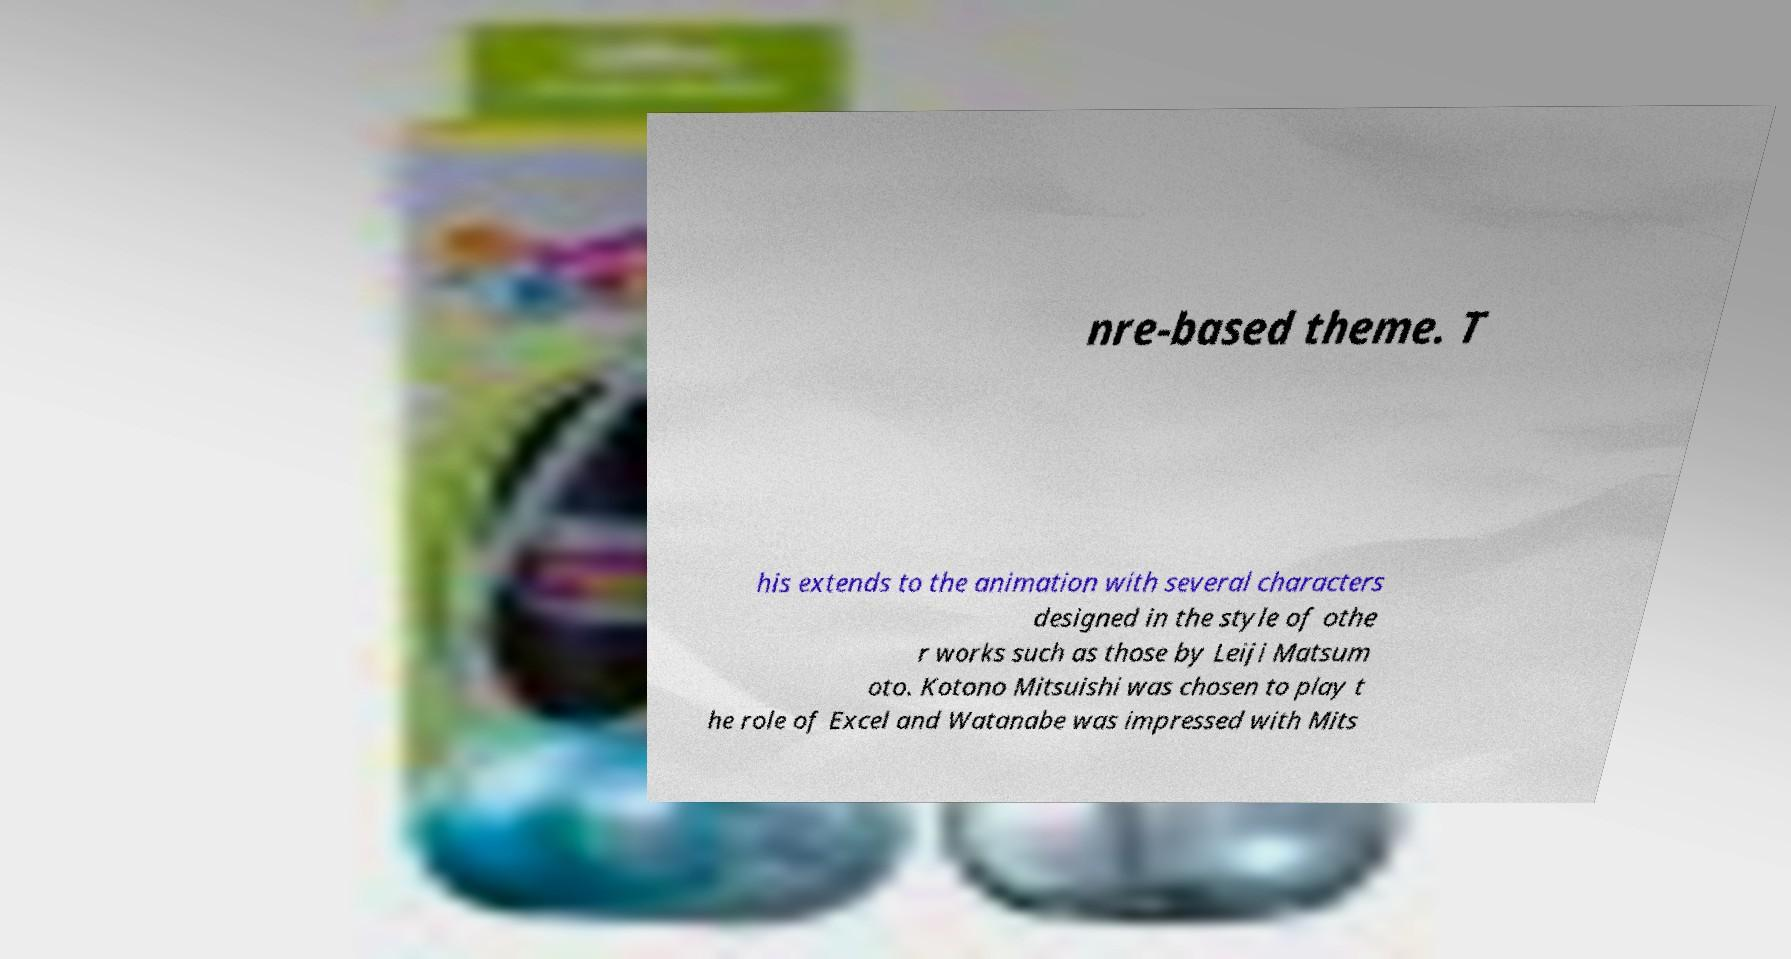Can you accurately transcribe the text from the provided image for me? nre-based theme. T his extends to the animation with several characters designed in the style of othe r works such as those by Leiji Matsum oto. Kotono Mitsuishi was chosen to play t he role of Excel and Watanabe was impressed with Mits 